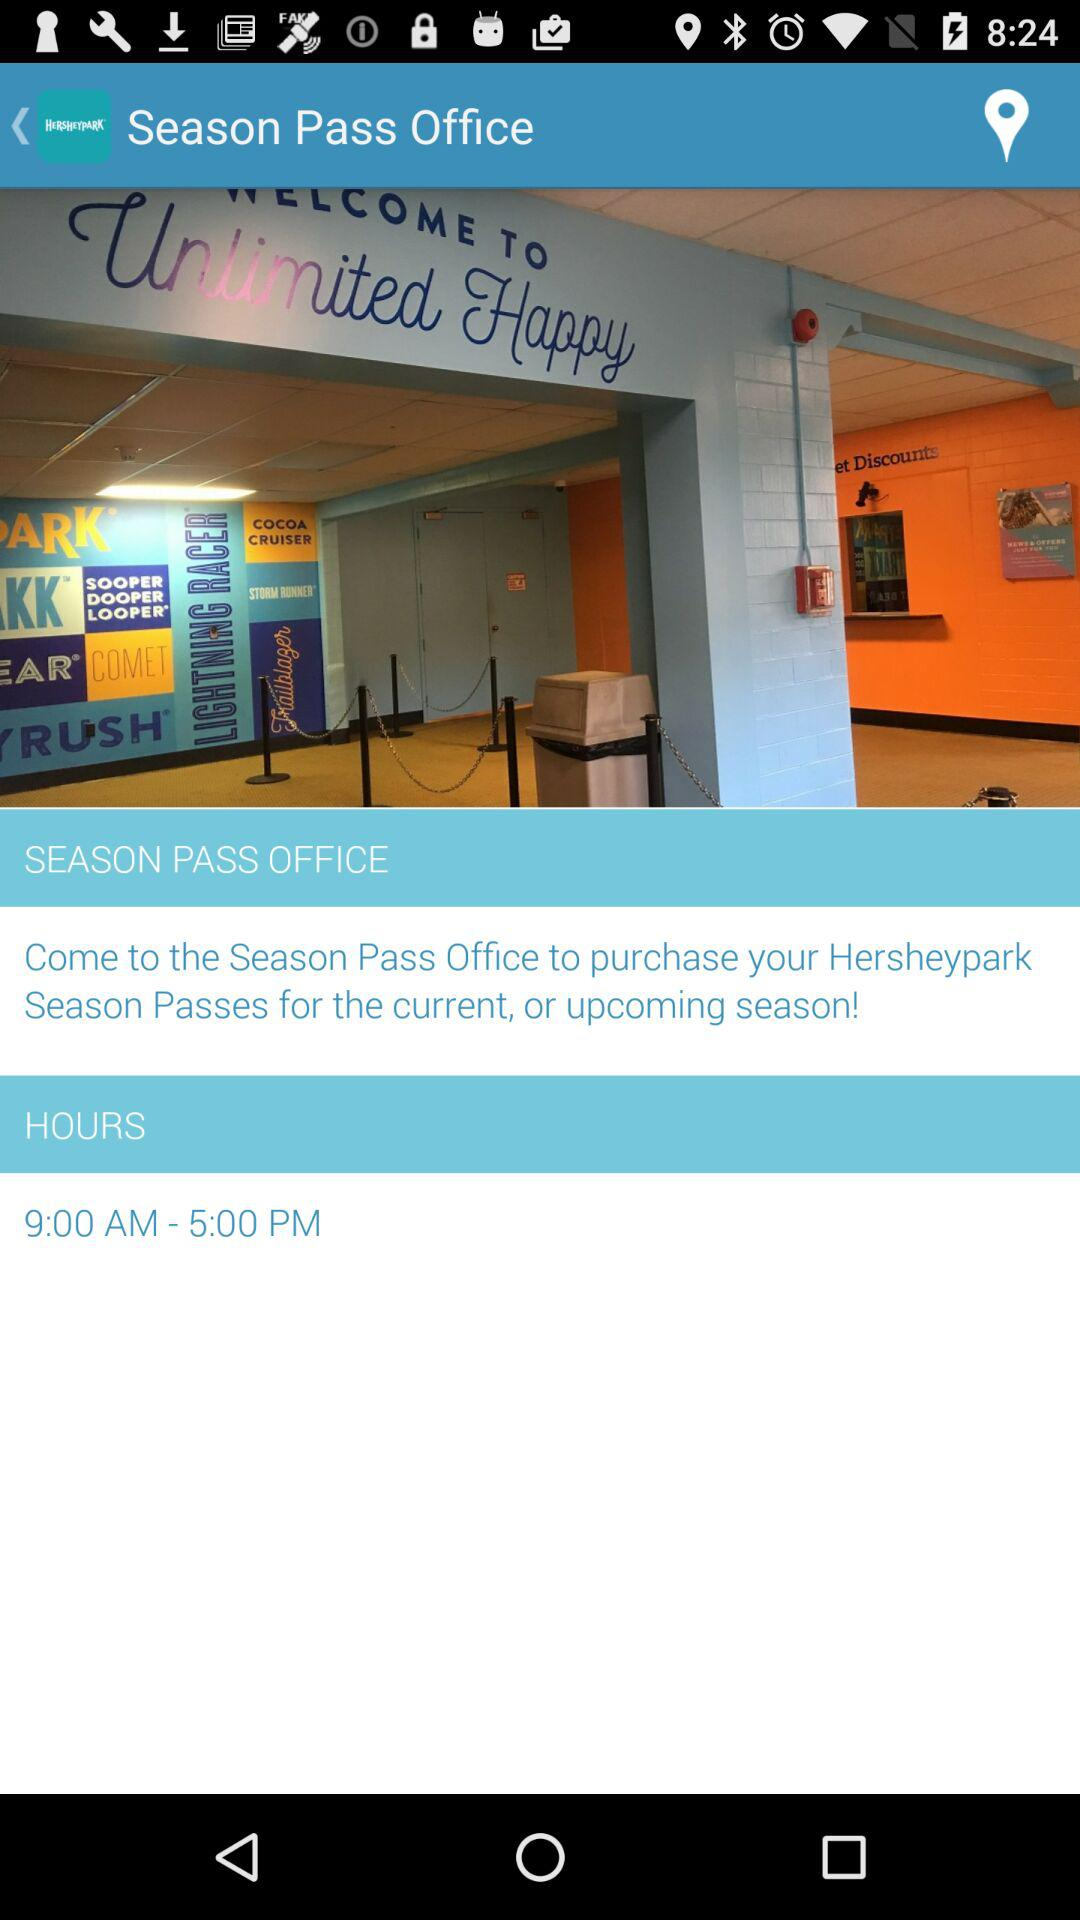What are the office hours? The office hours are from 9:00 a.m. to 5:00 p.m. 